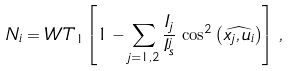<formula> <loc_0><loc_0><loc_500><loc_500>N _ { i } = W T _ { 1 } \left [ 1 - \sum _ { j = 1 , 2 } \frac { I _ { j } } { I _ { s } ^ { j } } \, \cos ^ { 2 } \left ( \widehat { x _ { j } , u _ { i } } \right ) \right ] \, ,</formula> 